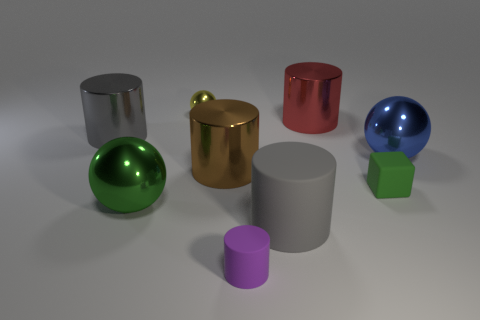There is a large metallic sphere left of the purple matte cylinder; does it have the same color as the small matte thing behind the green metal sphere?
Your answer should be compact. Yes. Is the number of yellow shiny objects left of the large brown metallic cylinder greater than the number of big red cylinders to the left of the large red thing?
Make the answer very short. Yes. There is another rubber thing that is the same shape as the tiny purple matte thing; what color is it?
Keep it short and to the point. Gray. Is there anything else that is the same shape as the tiny green rubber thing?
Keep it short and to the point. No. Do the green shiny thing and the green object on the right side of the small ball have the same shape?
Your answer should be very brief. No. What number of other things are there of the same material as the small green cube
Your response must be concise. 2. Does the tiny cube have the same color as the big shiny ball that is to the right of the tiny yellow sphere?
Provide a succinct answer. No. There is a ball on the left side of the tiny yellow shiny object; what is its material?
Your response must be concise. Metal. Are there any objects of the same color as the cube?
Offer a very short reply. Yes. There is another matte cylinder that is the same size as the red cylinder; what color is it?
Ensure brevity in your answer.  Gray. 